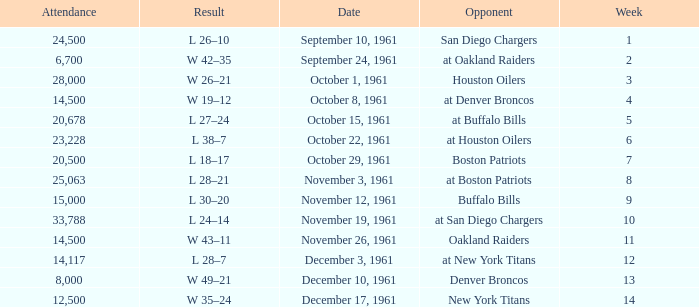What is the low attendance rate against buffalo bills? 15000.0. 